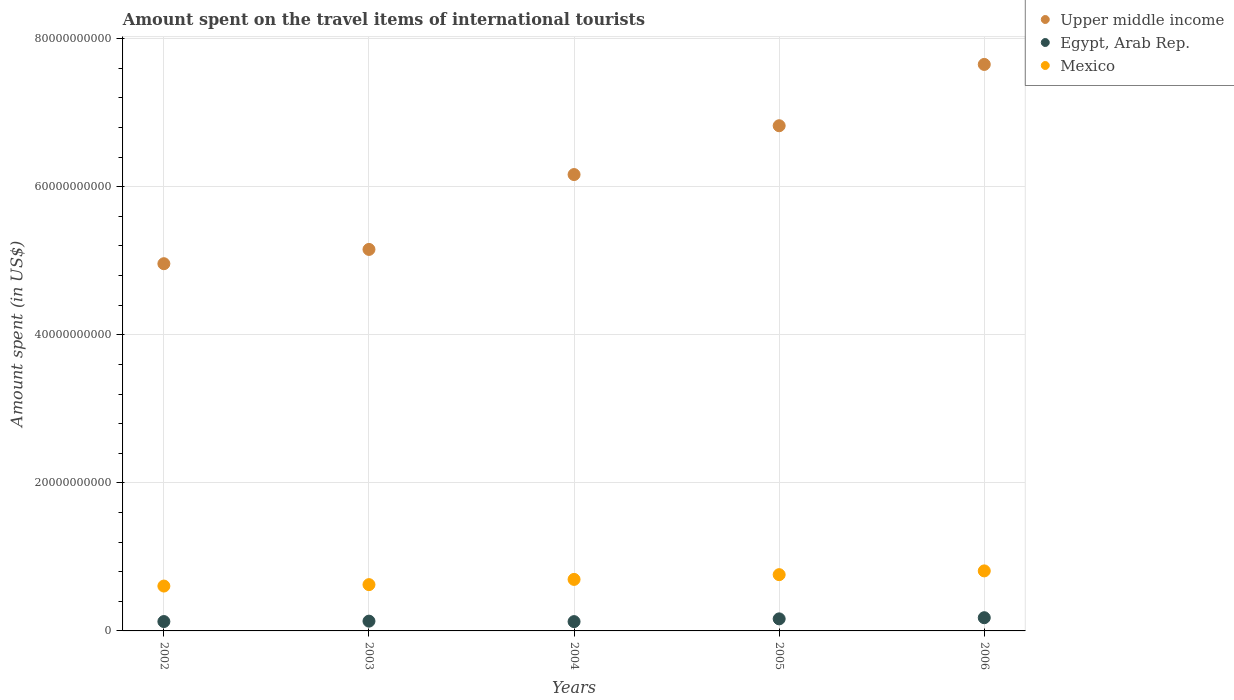How many different coloured dotlines are there?
Give a very brief answer. 3. Is the number of dotlines equal to the number of legend labels?
Provide a short and direct response. Yes. What is the amount spent on the travel items of international tourists in Mexico in 2006?
Offer a terse response. 8.11e+09. Across all years, what is the maximum amount spent on the travel items of international tourists in Upper middle income?
Your answer should be compact. 7.65e+1. Across all years, what is the minimum amount spent on the travel items of international tourists in Upper middle income?
Provide a short and direct response. 4.96e+1. In which year was the amount spent on the travel items of international tourists in Egypt, Arab Rep. maximum?
Provide a short and direct response. 2006. In which year was the amount spent on the travel items of international tourists in Egypt, Arab Rep. minimum?
Your response must be concise. 2004. What is the total amount spent on the travel items of international tourists in Upper middle income in the graph?
Make the answer very short. 3.08e+11. What is the difference between the amount spent on the travel items of international tourists in Egypt, Arab Rep. in 2002 and that in 2003?
Offer a very short reply. -5.50e+07. What is the difference between the amount spent on the travel items of international tourists in Mexico in 2004 and the amount spent on the travel items of international tourists in Egypt, Arab Rep. in 2005?
Provide a succinct answer. 5.33e+09. What is the average amount spent on the travel items of international tourists in Mexico per year?
Offer a terse response. 7.00e+09. In the year 2003, what is the difference between the amount spent on the travel items of international tourists in Mexico and amount spent on the travel items of international tourists in Egypt, Arab Rep.?
Give a very brief answer. 4.93e+09. What is the ratio of the amount spent on the travel items of international tourists in Mexico in 2002 to that in 2003?
Your response must be concise. 0.97. Is the amount spent on the travel items of international tourists in Upper middle income in 2002 less than that in 2006?
Ensure brevity in your answer.  Yes. What is the difference between the highest and the second highest amount spent on the travel items of international tourists in Mexico?
Give a very brief answer. 5.08e+08. What is the difference between the highest and the lowest amount spent on the travel items of international tourists in Mexico?
Offer a very short reply. 2.05e+09. Is the sum of the amount spent on the travel items of international tourists in Egypt, Arab Rep. in 2003 and 2005 greater than the maximum amount spent on the travel items of international tourists in Mexico across all years?
Provide a succinct answer. No. Does the amount spent on the travel items of international tourists in Mexico monotonically increase over the years?
Offer a very short reply. Yes. Is the amount spent on the travel items of international tourists in Mexico strictly greater than the amount spent on the travel items of international tourists in Upper middle income over the years?
Keep it short and to the point. No. How many dotlines are there?
Give a very brief answer. 3. How many years are there in the graph?
Make the answer very short. 5. Does the graph contain grids?
Make the answer very short. Yes. How are the legend labels stacked?
Your response must be concise. Vertical. What is the title of the graph?
Offer a terse response. Amount spent on the travel items of international tourists. Does "Peru" appear as one of the legend labels in the graph?
Provide a succinct answer. No. What is the label or title of the X-axis?
Offer a terse response. Years. What is the label or title of the Y-axis?
Your response must be concise. Amount spent (in US$). What is the Amount spent (in US$) of Upper middle income in 2002?
Provide a succinct answer. 4.96e+1. What is the Amount spent (in US$) in Egypt, Arab Rep. in 2002?
Make the answer very short. 1.27e+09. What is the Amount spent (in US$) of Mexico in 2002?
Provide a short and direct response. 6.06e+09. What is the Amount spent (in US$) of Upper middle income in 2003?
Your response must be concise. 5.15e+1. What is the Amount spent (in US$) in Egypt, Arab Rep. in 2003?
Your response must be concise. 1.32e+09. What is the Amount spent (in US$) in Mexico in 2003?
Offer a terse response. 6.25e+09. What is the Amount spent (in US$) in Upper middle income in 2004?
Provide a succinct answer. 6.16e+1. What is the Amount spent (in US$) of Egypt, Arab Rep. in 2004?
Your response must be concise. 1.26e+09. What is the Amount spent (in US$) of Mexico in 2004?
Keep it short and to the point. 6.96e+09. What is the Amount spent (in US$) in Upper middle income in 2005?
Offer a terse response. 6.82e+1. What is the Amount spent (in US$) in Egypt, Arab Rep. in 2005?
Make the answer very short. 1.63e+09. What is the Amount spent (in US$) in Mexico in 2005?
Offer a terse response. 7.60e+09. What is the Amount spent (in US$) in Upper middle income in 2006?
Give a very brief answer. 7.65e+1. What is the Amount spent (in US$) of Egypt, Arab Rep. in 2006?
Provide a short and direct response. 1.78e+09. What is the Amount spent (in US$) of Mexico in 2006?
Give a very brief answer. 8.11e+09. Across all years, what is the maximum Amount spent (in US$) in Upper middle income?
Provide a succinct answer. 7.65e+1. Across all years, what is the maximum Amount spent (in US$) in Egypt, Arab Rep.?
Provide a succinct answer. 1.78e+09. Across all years, what is the maximum Amount spent (in US$) of Mexico?
Offer a terse response. 8.11e+09. Across all years, what is the minimum Amount spent (in US$) of Upper middle income?
Keep it short and to the point. 4.96e+1. Across all years, what is the minimum Amount spent (in US$) in Egypt, Arab Rep.?
Provide a succinct answer. 1.26e+09. Across all years, what is the minimum Amount spent (in US$) in Mexico?
Your answer should be compact. 6.06e+09. What is the total Amount spent (in US$) in Upper middle income in the graph?
Give a very brief answer. 3.08e+11. What is the total Amount spent (in US$) in Egypt, Arab Rep. in the graph?
Make the answer very short. 7.26e+09. What is the total Amount spent (in US$) in Mexico in the graph?
Your answer should be compact. 3.50e+1. What is the difference between the Amount spent (in US$) in Upper middle income in 2002 and that in 2003?
Make the answer very short. -1.93e+09. What is the difference between the Amount spent (in US$) of Egypt, Arab Rep. in 2002 and that in 2003?
Ensure brevity in your answer.  -5.50e+07. What is the difference between the Amount spent (in US$) in Mexico in 2002 and that in 2003?
Keep it short and to the point. -1.93e+08. What is the difference between the Amount spent (in US$) of Upper middle income in 2002 and that in 2004?
Offer a very short reply. -1.20e+1. What is the difference between the Amount spent (in US$) of Egypt, Arab Rep. in 2002 and that in 2004?
Give a very brief answer. 9.00e+06. What is the difference between the Amount spent (in US$) in Mexico in 2002 and that in 2004?
Your answer should be compact. -8.99e+08. What is the difference between the Amount spent (in US$) in Upper middle income in 2002 and that in 2005?
Your answer should be compact. -1.86e+1. What is the difference between the Amount spent (in US$) of Egypt, Arab Rep. in 2002 and that in 2005?
Ensure brevity in your answer.  -3.63e+08. What is the difference between the Amount spent (in US$) of Mexico in 2002 and that in 2005?
Offer a very short reply. -1.54e+09. What is the difference between the Amount spent (in US$) in Upper middle income in 2002 and that in 2006?
Keep it short and to the point. -2.69e+1. What is the difference between the Amount spent (in US$) of Egypt, Arab Rep. in 2002 and that in 2006?
Keep it short and to the point. -5.18e+08. What is the difference between the Amount spent (in US$) of Mexico in 2002 and that in 2006?
Ensure brevity in your answer.  -2.05e+09. What is the difference between the Amount spent (in US$) in Upper middle income in 2003 and that in 2004?
Give a very brief answer. -1.01e+1. What is the difference between the Amount spent (in US$) of Egypt, Arab Rep. in 2003 and that in 2004?
Your response must be concise. 6.40e+07. What is the difference between the Amount spent (in US$) in Mexico in 2003 and that in 2004?
Offer a very short reply. -7.06e+08. What is the difference between the Amount spent (in US$) in Upper middle income in 2003 and that in 2005?
Keep it short and to the point. -1.67e+1. What is the difference between the Amount spent (in US$) in Egypt, Arab Rep. in 2003 and that in 2005?
Your answer should be compact. -3.08e+08. What is the difference between the Amount spent (in US$) in Mexico in 2003 and that in 2005?
Keep it short and to the point. -1.35e+09. What is the difference between the Amount spent (in US$) in Upper middle income in 2003 and that in 2006?
Your answer should be compact. -2.50e+1. What is the difference between the Amount spent (in US$) of Egypt, Arab Rep. in 2003 and that in 2006?
Provide a short and direct response. -4.63e+08. What is the difference between the Amount spent (in US$) of Mexico in 2003 and that in 2006?
Provide a short and direct response. -1.86e+09. What is the difference between the Amount spent (in US$) in Upper middle income in 2004 and that in 2005?
Offer a terse response. -6.59e+09. What is the difference between the Amount spent (in US$) in Egypt, Arab Rep. in 2004 and that in 2005?
Make the answer very short. -3.72e+08. What is the difference between the Amount spent (in US$) in Mexico in 2004 and that in 2005?
Offer a very short reply. -6.41e+08. What is the difference between the Amount spent (in US$) of Upper middle income in 2004 and that in 2006?
Give a very brief answer. -1.49e+1. What is the difference between the Amount spent (in US$) of Egypt, Arab Rep. in 2004 and that in 2006?
Keep it short and to the point. -5.27e+08. What is the difference between the Amount spent (in US$) in Mexico in 2004 and that in 2006?
Provide a short and direct response. -1.15e+09. What is the difference between the Amount spent (in US$) of Upper middle income in 2005 and that in 2006?
Your answer should be very brief. -8.28e+09. What is the difference between the Amount spent (in US$) in Egypt, Arab Rep. in 2005 and that in 2006?
Provide a short and direct response. -1.55e+08. What is the difference between the Amount spent (in US$) in Mexico in 2005 and that in 2006?
Offer a terse response. -5.08e+08. What is the difference between the Amount spent (in US$) of Upper middle income in 2002 and the Amount spent (in US$) of Egypt, Arab Rep. in 2003?
Give a very brief answer. 4.83e+1. What is the difference between the Amount spent (in US$) of Upper middle income in 2002 and the Amount spent (in US$) of Mexico in 2003?
Offer a terse response. 4.33e+1. What is the difference between the Amount spent (in US$) in Egypt, Arab Rep. in 2002 and the Amount spent (in US$) in Mexico in 2003?
Give a very brief answer. -4.99e+09. What is the difference between the Amount spent (in US$) of Upper middle income in 2002 and the Amount spent (in US$) of Egypt, Arab Rep. in 2004?
Provide a succinct answer. 4.83e+1. What is the difference between the Amount spent (in US$) of Upper middle income in 2002 and the Amount spent (in US$) of Mexico in 2004?
Provide a succinct answer. 4.26e+1. What is the difference between the Amount spent (in US$) of Egypt, Arab Rep. in 2002 and the Amount spent (in US$) of Mexico in 2004?
Offer a very short reply. -5.69e+09. What is the difference between the Amount spent (in US$) of Upper middle income in 2002 and the Amount spent (in US$) of Egypt, Arab Rep. in 2005?
Your answer should be very brief. 4.80e+1. What is the difference between the Amount spent (in US$) in Upper middle income in 2002 and the Amount spent (in US$) in Mexico in 2005?
Your answer should be compact. 4.20e+1. What is the difference between the Amount spent (in US$) of Egypt, Arab Rep. in 2002 and the Amount spent (in US$) of Mexico in 2005?
Keep it short and to the point. -6.33e+09. What is the difference between the Amount spent (in US$) of Upper middle income in 2002 and the Amount spent (in US$) of Egypt, Arab Rep. in 2006?
Provide a short and direct response. 4.78e+1. What is the difference between the Amount spent (in US$) of Upper middle income in 2002 and the Amount spent (in US$) of Mexico in 2006?
Your answer should be compact. 4.15e+1. What is the difference between the Amount spent (in US$) of Egypt, Arab Rep. in 2002 and the Amount spent (in US$) of Mexico in 2006?
Your answer should be very brief. -6.84e+09. What is the difference between the Amount spent (in US$) in Upper middle income in 2003 and the Amount spent (in US$) in Egypt, Arab Rep. in 2004?
Provide a succinct answer. 5.03e+1. What is the difference between the Amount spent (in US$) of Upper middle income in 2003 and the Amount spent (in US$) of Mexico in 2004?
Give a very brief answer. 4.46e+1. What is the difference between the Amount spent (in US$) of Egypt, Arab Rep. in 2003 and the Amount spent (in US$) of Mexico in 2004?
Ensure brevity in your answer.  -5.64e+09. What is the difference between the Amount spent (in US$) of Upper middle income in 2003 and the Amount spent (in US$) of Egypt, Arab Rep. in 2005?
Provide a short and direct response. 4.99e+1. What is the difference between the Amount spent (in US$) in Upper middle income in 2003 and the Amount spent (in US$) in Mexico in 2005?
Keep it short and to the point. 4.39e+1. What is the difference between the Amount spent (in US$) of Egypt, Arab Rep. in 2003 and the Amount spent (in US$) of Mexico in 2005?
Your answer should be very brief. -6.28e+09. What is the difference between the Amount spent (in US$) of Upper middle income in 2003 and the Amount spent (in US$) of Egypt, Arab Rep. in 2006?
Make the answer very short. 4.97e+1. What is the difference between the Amount spent (in US$) of Upper middle income in 2003 and the Amount spent (in US$) of Mexico in 2006?
Give a very brief answer. 4.34e+1. What is the difference between the Amount spent (in US$) of Egypt, Arab Rep. in 2003 and the Amount spent (in US$) of Mexico in 2006?
Your answer should be very brief. -6.79e+09. What is the difference between the Amount spent (in US$) of Upper middle income in 2004 and the Amount spent (in US$) of Egypt, Arab Rep. in 2005?
Give a very brief answer. 6.00e+1. What is the difference between the Amount spent (in US$) in Upper middle income in 2004 and the Amount spent (in US$) in Mexico in 2005?
Ensure brevity in your answer.  5.40e+1. What is the difference between the Amount spent (in US$) of Egypt, Arab Rep. in 2004 and the Amount spent (in US$) of Mexico in 2005?
Provide a succinct answer. -6.34e+09. What is the difference between the Amount spent (in US$) of Upper middle income in 2004 and the Amount spent (in US$) of Egypt, Arab Rep. in 2006?
Make the answer very short. 5.99e+1. What is the difference between the Amount spent (in US$) of Upper middle income in 2004 and the Amount spent (in US$) of Mexico in 2006?
Provide a succinct answer. 5.35e+1. What is the difference between the Amount spent (in US$) in Egypt, Arab Rep. in 2004 and the Amount spent (in US$) in Mexico in 2006?
Provide a short and direct response. -6.85e+09. What is the difference between the Amount spent (in US$) of Upper middle income in 2005 and the Amount spent (in US$) of Egypt, Arab Rep. in 2006?
Your response must be concise. 6.65e+1. What is the difference between the Amount spent (in US$) of Upper middle income in 2005 and the Amount spent (in US$) of Mexico in 2006?
Offer a very short reply. 6.01e+1. What is the difference between the Amount spent (in US$) of Egypt, Arab Rep. in 2005 and the Amount spent (in US$) of Mexico in 2006?
Your response must be concise. -6.48e+09. What is the average Amount spent (in US$) of Upper middle income per year?
Offer a very short reply. 6.15e+1. What is the average Amount spent (in US$) in Egypt, Arab Rep. per year?
Ensure brevity in your answer.  1.45e+09. What is the average Amount spent (in US$) in Mexico per year?
Ensure brevity in your answer.  7.00e+09. In the year 2002, what is the difference between the Amount spent (in US$) of Upper middle income and Amount spent (in US$) of Egypt, Arab Rep.?
Your answer should be very brief. 4.83e+1. In the year 2002, what is the difference between the Amount spent (in US$) of Upper middle income and Amount spent (in US$) of Mexico?
Make the answer very short. 4.35e+1. In the year 2002, what is the difference between the Amount spent (in US$) in Egypt, Arab Rep. and Amount spent (in US$) in Mexico?
Keep it short and to the point. -4.79e+09. In the year 2003, what is the difference between the Amount spent (in US$) in Upper middle income and Amount spent (in US$) in Egypt, Arab Rep.?
Provide a short and direct response. 5.02e+1. In the year 2003, what is the difference between the Amount spent (in US$) in Upper middle income and Amount spent (in US$) in Mexico?
Offer a terse response. 4.53e+1. In the year 2003, what is the difference between the Amount spent (in US$) in Egypt, Arab Rep. and Amount spent (in US$) in Mexico?
Keep it short and to the point. -4.93e+09. In the year 2004, what is the difference between the Amount spent (in US$) of Upper middle income and Amount spent (in US$) of Egypt, Arab Rep.?
Provide a succinct answer. 6.04e+1. In the year 2004, what is the difference between the Amount spent (in US$) of Upper middle income and Amount spent (in US$) of Mexico?
Give a very brief answer. 5.47e+1. In the year 2004, what is the difference between the Amount spent (in US$) of Egypt, Arab Rep. and Amount spent (in US$) of Mexico?
Offer a very short reply. -5.70e+09. In the year 2005, what is the difference between the Amount spent (in US$) in Upper middle income and Amount spent (in US$) in Egypt, Arab Rep.?
Provide a succinct answer. 6.66e+1. In the year 2005, what is the difference between the Amount spent (in US$) in Upper middle income and Amount spent (in US$) in Mexico?
Offer a very short reply. 6.06e+1. In the year 2005, what is the difference between the Amount spent (in US$) of Egypt, Arab Rep. and Amount spent (in US$) of Mexico?
Offer a terse response. -5.97e+09. In the year 2006, what is the difference between the Amount spent (in US$) in Upper middle income and Amount spent (in US$) in Egypt, Arab Rep.?
Provide a succinct answer. 7.47e+1. In the year 2006, what is the difference between the Amount spent (in US$) in Upper middle income and Amount spent (in US$) in Mexico?
Make the answer very short. 6.84e+1. In the year 2006, what is the difference between the Amount spent (in US$) in Egypt, Arab Rep. and Amount spent (in US$) in Mexico?
Keep it short and to the point. -6.32e+09. What is the ratio of the Amount spent (in US$) of Upper middle income in 2002 to that in 2003?
Make the answer very short. 0.96. What is the ratio of the Amount spent (in US$) in Egypt, Arab Rep. in 2002 to that in 2003?
Offer a very short reply. 0.96. What is the ratio of the Amount spent (in US$) of Mexico in 2002 to that in 2003?
Provide a short and direct response. 0.97. What is the ratio of the Amount spent (in US$) of Upper middle income in 2002 to that in 2004?
Provide a short and direct response. 0.8. What is the ratio of the Amount spent (in US$) in Mexico in 2002 to that in 2004?
Your answer should be compact. 0.87. What is the ratio of the Amount spent (in US$) in Upper middle income in 2002 to that in 2005?
Offer a terse response. 0.73. What is the ratio of the Amount spent (in US$) of Egypt, Arab Rep. in 2002 to that in 2005?
Make the answer very short. 0.78. What is the ratio of the Amount spent (in US$) in Mexico in 2002 to that in 2005?
Give a very brief answer. 0.8. What is the ratio of the Amount spent (in US$) of Upper middle income in 2002 to that in 2006?
Give a very brief answer. 0.65. What is the ratio of the Amount spent (in US$) in Egypt, Arab Rep. in 2002 to that in 2006?
Provide a short and direct response. 0.71. What is the ratio of the Amount spent (in US$) of Mexico in 2002 to that in 2006?
Provide a succinct answer. 0.75. What is the ratio of the Amount spent (in US$) in Upper middle income in 2003 to that in 2004?
Make the answer very short. 0.84. What is the ratio of the Amount spent (in US$) in Egypt, Arab Rep. in 2003 to that in 2004?
Your response must be concise. 1.05. What is the ratio of the Amount spent (in US$) of Mexico in 2003 to that in 2004?
Offer a terse response. 0.9. What is the ratio of the Amount spent (in US$) of Upper middle income in 2003 to that in 2005?
Keep it short and to the point. 0.76. What is the ratio of the Amount spent (in US$) of Egypt, Arab Rep. in 2003 to that in 2005?
Give a very brief answer. 0.81. What is the ratio of the Amount spent (in US$) in Mexico in 2003 to that in 2005?
Offer a terse response. 0.82. What is the ratio of the Amount spent (in US$) of Upper middle income in 2003 to that in 2006?
Offer a terse response. 0.67. What is the ratio of the Amount spent (in US$) in Egypt, Arab Rep. in 2003 to that in 2006?
Offer a terse response. 0.74. What is the ratio of the Amount spent (in US$) in Mexico in 2003 to that in 2006?
Ensure brevity in your answer.  0.77. What is the ratio of the Amount spent (in US$) of Upper middle income in 2004 to that in 2005?
Offer a terse response. 0.9. What is the ratio of the Amount spent (in US$) of Egypt, Arab Rep. in 2004 to that in 2005?
Keep it short and to the point. 0.77. What is the ratio of the Amount spent (in US$) in Mexico in 2004 to that in 2005?
Provide a short and direct response. 0.92. What is the ratio of the Amount spent (in US$) in Upper middle income in 2004 to that in 2006?
Ensure brevity in your answer.  0.81. What is the ratio of the Amount spent (in US$) in Egypt, Arab Rep. in 2004 to that in 2006?
Provide a short and direct response. 0.7. What is the ratio of the Amount spent (in US$) of Mexico in 2004 to that in 2006?
Provide a short and direct response. 0.86. What is the ratio of the Amount spent (in US$) of Upper middle income in 2005 to that in 2006?
Your answer should be very brief. 0.89. What is the ratio of the Amount spent (in US$) in Egypt, Arab Rep. in 2005 to that in 2006?
Make the answer very short. 0.91. What is the ratio of the Amount spent (in US$) of Mexico in 2005 to that in 2006?
Offer a very short reply. 0.94. What is the difference between the highest and the second highest Amount spent (in US$) of Upper middle income?
Your answer should be compact. 8.28e+09. What is the difference between the highest and the second highest Amount spent (in US$) of Egypt, Arab Rep.?
Offer a very short reply. 1.55e+08. What is the difference between the highest and the second highest Amount spent (in US$) of Mexico?
Your answer should be very brief. 5.08e+08. What is the difference between the highest and the lowest Amount spent (in US$) of Upper middle income?
Keep it short and to the point. 2.69e+1. What is the difference between the highest and the lowest Amount spent (in US$) in Egypt, Arab Rep.?
Give a very brief answer. 5.27e+08. What is the difference between the highest and the lowest Amount spent (in US$) in Mexico?
Your answer should be very brief. 2.05e+09. 